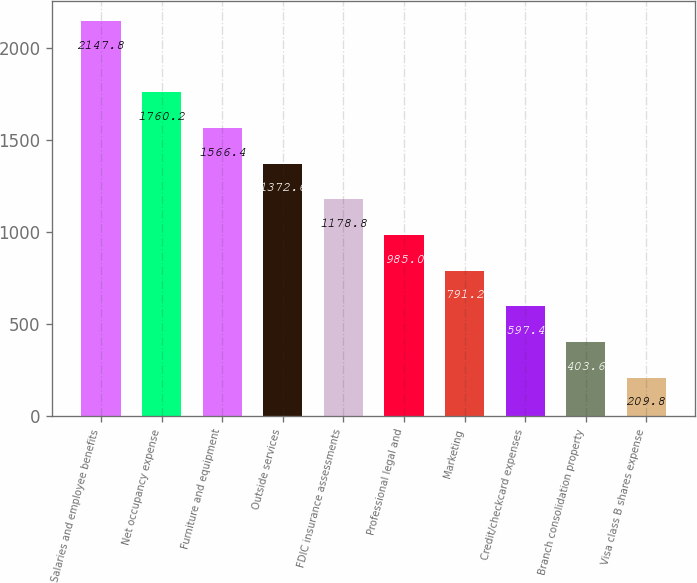<chart> <loc_0><loc_0><loc_500><loc_500><bar_chart><fcel>Salaries and employee benefits<fcel>Net occupancy expense<fcel>Furniture and equipment<fcel>Outside services<fcel>FDIC insurance assessments<fcel>Professional legal and<fcel>Marketing<fcel>Credit/checkcard expenses<fcel>Branch consolidation property<fcel>Visa class B shares expense<nl><fcel>2147.8<fcel>1760.2<fcel>1566.4<fcel>1372.6<fcel>1178.8<fcel>985<fcel>791.2<fcel>597.4<fcel>403.6<fcel>209.8<nl></chart> 